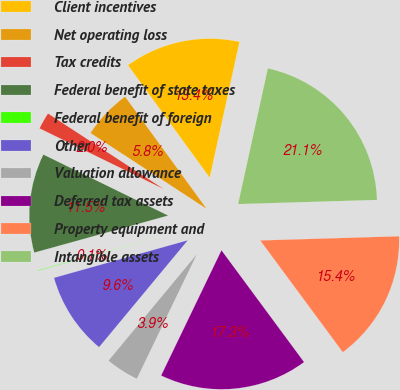<chart> <loc_0><loc_0><loc_500><loc_500><pie_chart><fcel>Client incentives<fcel>Net operating loss<fcel>Tax credits<fcel>Federal benefit of state taxes<fcel>Federal benefit of foreign<fcel>Other<fcel>Valuation allowance<fcel>Deferred tax assets<fcel>Property equipment and<fcel>Intangible assets<nl><fcel>13.44%<fcel>5.79%<fcel>1.97%<fcel>11.53%<fcel>0.06%<fcel>9.62%<fcel>3.88%<fcel>17.27%<fcel>15.35%<fcel>21.09%<nl></chart> 